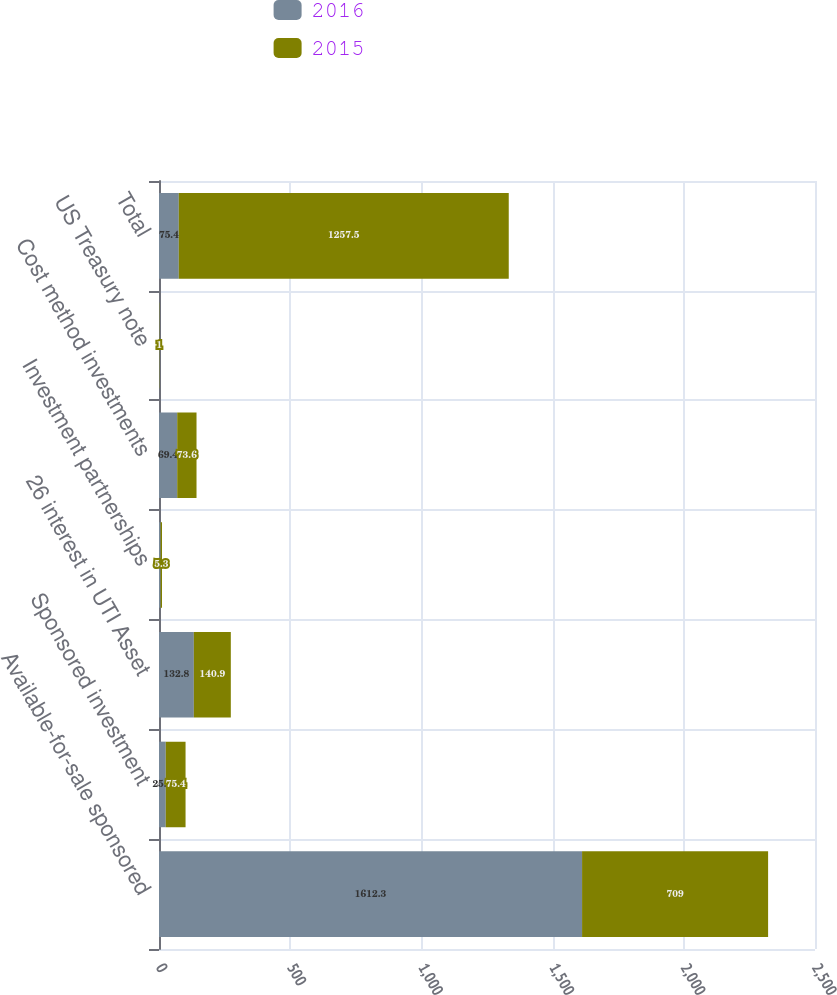Convert chart. <chart><loc_0><loc_0><loc_500><loc_500><stacked_bar_chart><ecel><fcel>Available-for-sale sponsored<fcel>Sponsored investment<fcel>26 interest in UTI Asset<fcel>Investment partnerships<fcel>Cost method investments<fcel>US Treasury note<fcel>Total<nl><fcel>2016<fcel>1612.3<fcel>25.8<fcel>132.8<fcel>6.2<fcel>69.4<fcel>1<fcel>75.4<nl><fcel>2015<fcel>709<fcel>75.4<fcel>140.9<fcel>5.3<fcel>73.6<fcel>1<fcel>1257.5<nl></chart> 